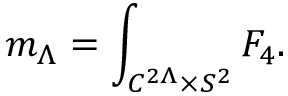<formula> <loc_0><loc_0><loc_500><loc_500>m _ { \Lambda } = \int _ { C ^ { 2 \Lambda } \times S ^ { 2 } } F _ { 4 } .</formula> 